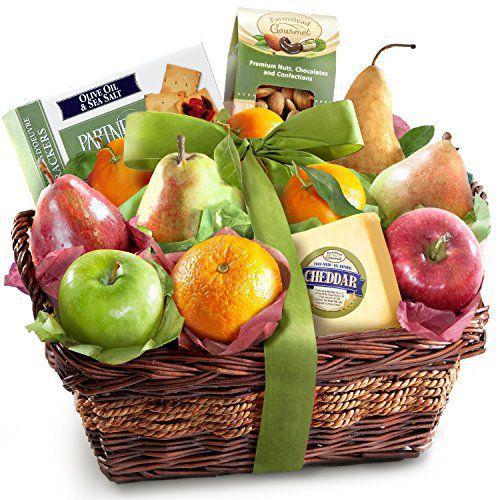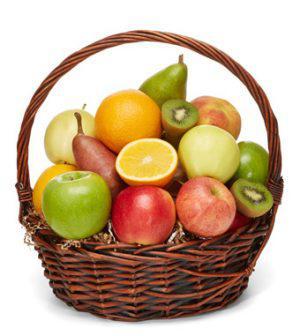The first image is the image on the left, the second image is the image on the right. Given the left and right images, does the statement "There are two wicker baskets." hold true? Answer yes or no. Yes. The first image is the image on the left, the second image is the image on the right. Examine the images to the left and right. Is the description "Each image features a woven basket filled with a variety of at least three kinds of fruit, and at least one image features a basket with a round handle." accurate? Answer yes or no. Yes. 